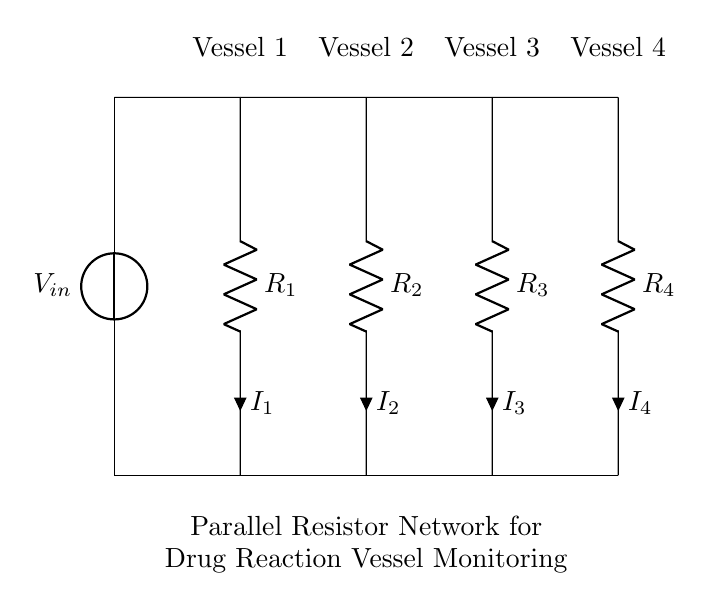What is the total number of resistance components in the circuit? There are four resistors present, labeled R1, R2, R3, and R4 in the circuit diagram. Each is connected in parallel, indicating the presence of four individual resistance components.
Answer: four What type of circuit configuration is depicted here? The circuit shows a parallel configuration where multiple components (the resistors) are connected to the same two nodes, allowing for multiple pathways for current to flow.
Answer: parallel What is the name of this circuit? This circuit is referred to as a Current Divider since it divides the input current among multiple paths created by the parallel resistors.
Answer: Current Divider How many drug reaction vessels are monitored simultaneously? The circuit includes four vessels labeled Vessel 1, Vessel 2, Vessel 3, and Vessel 4, indicating that it can monitor four separate drug reaction vessels at the same time.
Answer: four What can be inferred about the current flowing through each resistor? Each resistor will have a different current flowing through it, determined by its resistance value, following the current divider rule, where the total current splits inversely among the resistors according to their values.
Answer: different values If R1 has the lowest resistance, which vessel will receive the most current? Vessel 1 connected to R1 will receive the most current because in a current divider, the resistor with the lowest resistance allows more current to pass through it than those with higher resistance values.
Answer: Vessel 1 What would happen to the current distribution if one resistor is removed? Removing one resistor would alter the resistance network, potentially increasing the current through the remaining resistors since the total parallel resistance would decrease, leading to a different division of the total current among the remaining resistors.
Answer: alter current distribution 